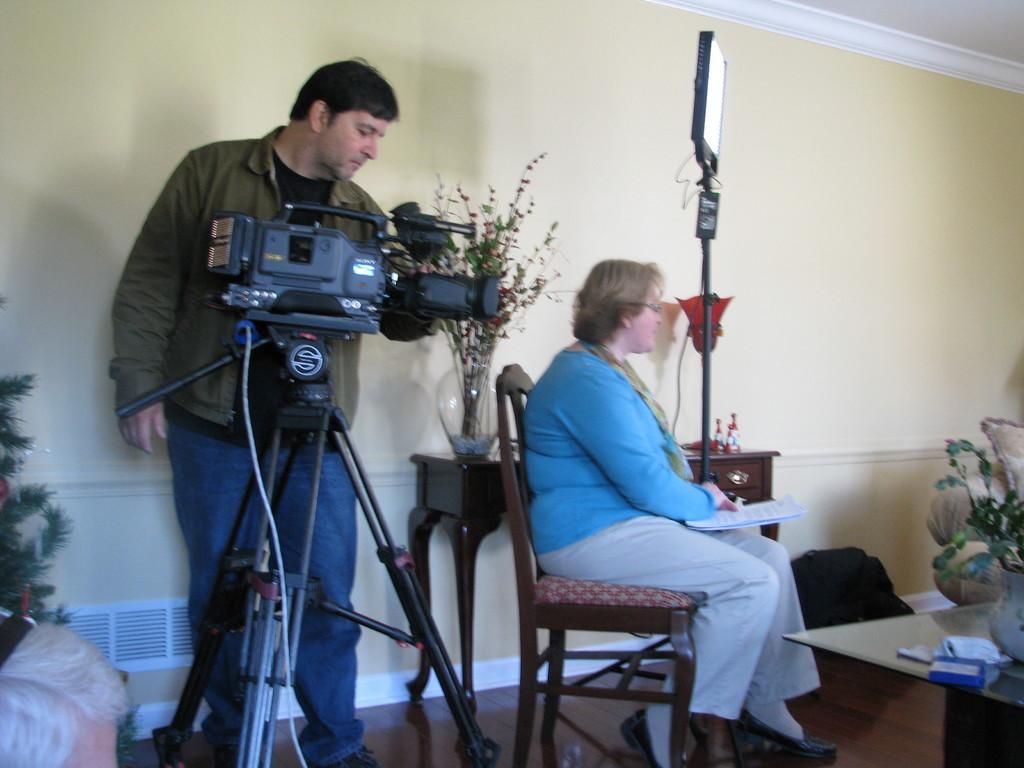In one or two sentences, can you explain what this image depicts? As we can see in the image there is a wall, camera. A man standing over here and there is a woman sitting on chair. In front of women there is a table. 